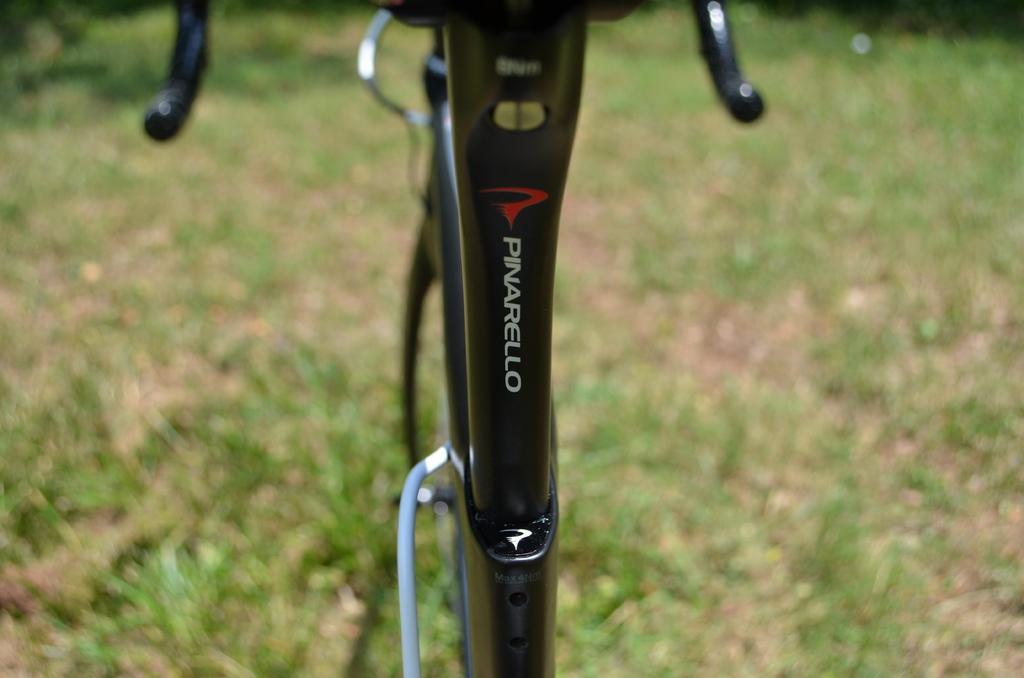Describe this image in one or two sentences. The picture is clicked outside. In the center we can see the black color metal objects seems to be a bicycle. In the background we can see the ground and the green grass. 